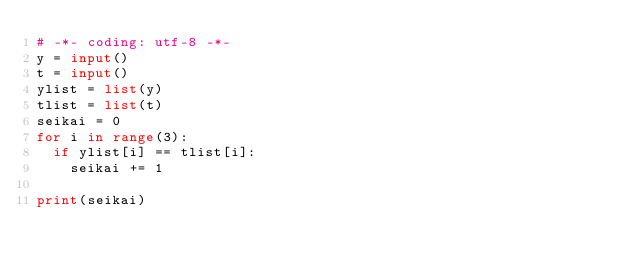Convert code to text. <code><loc_0><loc_0><loc_500><loc_500><_Python_># -*- coding: utf-8 -*-
y = input()
t = input()
ylist = list(y)
tlist = list(t)
seikai = 0
for i in range(3):
  if ylist[i] == tlist[i]:
    seikai += 1
    
print(seikai)</code> 